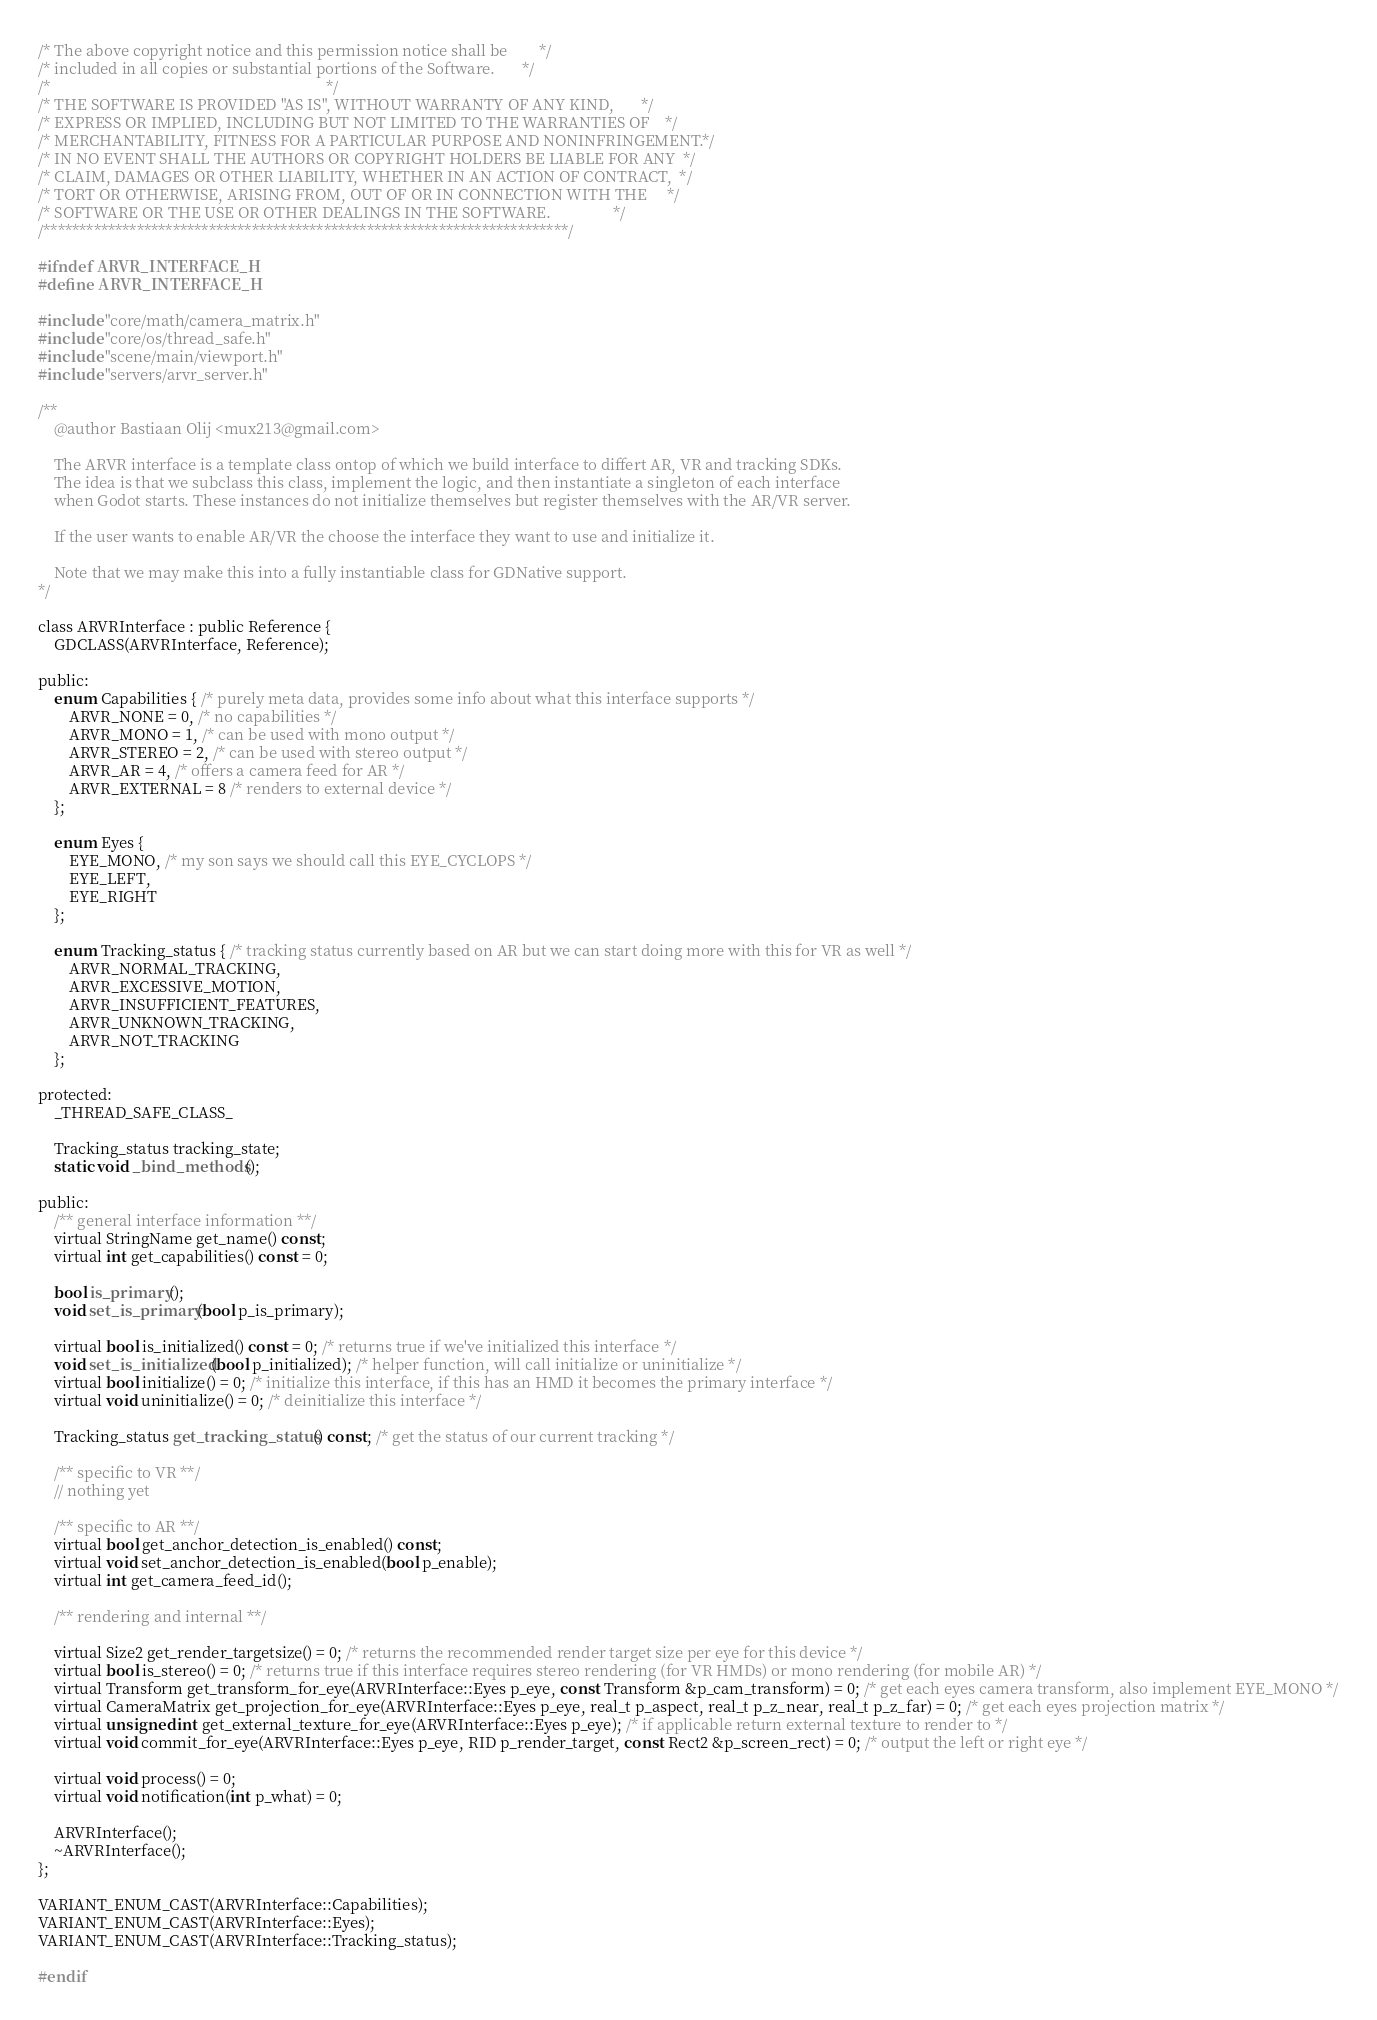Convert code to text. <code><loc_0><loc_0><loc_500><loc_500><_C_>/* The above copyright notice and this permission notice shall be        */
/* included in all copies or substantial portions of the Software.       */
/*                                                                       */
/* THE SOFTWARE IS PROVIDED "AS IS", WITHOUT WARRANTY OF ANY KIND,       */
/* EXPRESS OR IMPLIED, INCLUDING BUT NOT LIMITED TO THE WARRANTIES OF    */
/* MERCHANTABILITY, FITNESS FOR A PARTICULAR PURPOSE AND NONINFRINGEMENT.*/
/* IN NO EVENT SHALL THE AUTHORS OR COPYRIGHT HOLDERS BE LIABLE FOR ANY  */
/* CLAIM, DAMAGES OR OTHER LIABILITY, WHETHER IN AN ACTION OF CONTRACT,  */
/* TORT OR OTHERWISE, ARISING FROM, OUT OF OR IN CONNECTION WITH THE     */
/* SOFTWARE OR THE USE OR OTHER DEALINGS IN THE SOFTWARE.                */
/*************************************************************************/

#ifndef ARVR_INTERFACE_H
#define ARVR_INTERFACE_H

#include "core/math/camera_matrix.h"
#include "core/os/thread_safe.h"
#include "scene/main/viewport.h"
#include "servers/arvr_server.h"

/**
	@author Bastiaan Olij <mux213@gmail.com>

	The ARVR interface is a template class ontop of which we build interface to differt AR, VR and tracking SDKs.
	The idea is that we subclass this class, implement the logic, and then instantiate a singleton of each interface
	when Godot starts. These instances do not initialize themselves but register themselves with the AR/VR server.

	If the user wants to enable AR/VR the choose the interface they want to use and initialize it.

	Note that we may make this into a fully instantiable class for GDNative support.
*/

class ARVRInterface : public Reference {
	GDCLASS(ARVRInterface, Reference);

public:
	enum Capabilities { /* purely meta data, provides some info about what this interface supports */
		ARVR_NONE = 0, /* no capabilities */
		ARVR_MONO = 1, /* can be used with mono output */
		ARVR_STEREO = 2, /* can be used with stereo output */
		ARVR_AR = 4, /* offers a camera feed for AR */
		ARVR_EXTERNAL = 8 /* renders to external device */
	};

	enum Eyes {
		EYE_MONO, /* my son says we should call this EYE_CYCLOPS */
		EYE_LEFT,
		EYE_RIGHT
	};

	enum Tracking_status { /* tracking status currently based on AR but we can start doing more with this for VR as well */
		ARVR_NORMAL_TRACKING,
		ARVR_EXCESSIVE_MOTION,
		ARVR_INSUFFICIENT_FEATURES,
		ARVR_UNKNOWN_TRACKING,
		ARVR_NOT_TRACKING
	};

protected:
	_THREAD_SAFE_CLASS_

	Tracking_status tracking_state;
	static void _bind_methods();

public:
	/** general interface information **/
	virtual StringName get_name() const;
	virtual int get_capabilities() const = 0;

	bool is_primary();
	void set_is_primary(bool p_is_primary);

	virtual bool is_initialized() const = 0; /* returns true if we've initialized this interface */
	void set_is_initialized(bool p_initialized); /* helper function, will call initialize or uninitialize */
	virtual bool initialize() = 0; /* initialize this interface, if this has an HMD it becomes the primary interface */
	virtual void uninitialize() = 0; /* deinitialize this interface */

	Tracking_status get_tracking_status() const; /* get the status of our current tracking */

	/** specific to VR **/
	// nothing yet

	/** specific to AR **/
	virtual bool get_anchor_detection_is_enabled() const;
	virtual void set_anchor_detection_is_enabled(bool p_enable);
	virtual int get_camera_feed_id();

	/** rendering and internal **/

	virtual Size2 get_render_targetsize() = 0; /* returns the recommended render target size per eye for this device */
	virtual bool is_stereo() = 0; /* returns true if this interface requires stereo rendering (for VR HMDs) or mono rendering (for mobile AR) */
	virtual Transform get_transform_for_eye(ARVRInterface::Eyes p_eye, const Transform &p_cam_transform) = 0; /* get each eyes camera transform, also implement EYE_MONO */
	virtual CameraMatrix get_projection_for_eye(ARVRInterface::Eyes p_eye, real_t p_aspect, real_t p_z_near, real_t p_z_far) = 0; /* get each eyes projection matrix */
	virtual unsigned int get_external_texture_for_eye(ARVRInterface::Eyes p_eye); /* if applicable return external texture to render to */
	virtual void commit_for_eye(ARVRInterface::Eyes p_eye, RID p_render_target, const Rect2 &p_screen_rect) = 0; /* output the left or right eye */

	virtual void process() = 0;
	virtual void notification(int p_what) = 0;

	ARVRInterface();
	~ARVRInterface();
};

VARIANT_ENUM_CAST(ARVRInterface::Capabilities);
VARIANT_ENUM_CAST(ARVRInterface::Eyes);
VARIANT_ENUM_CAST(ARVRInterface::Tracking_status);

#endif
</code> 